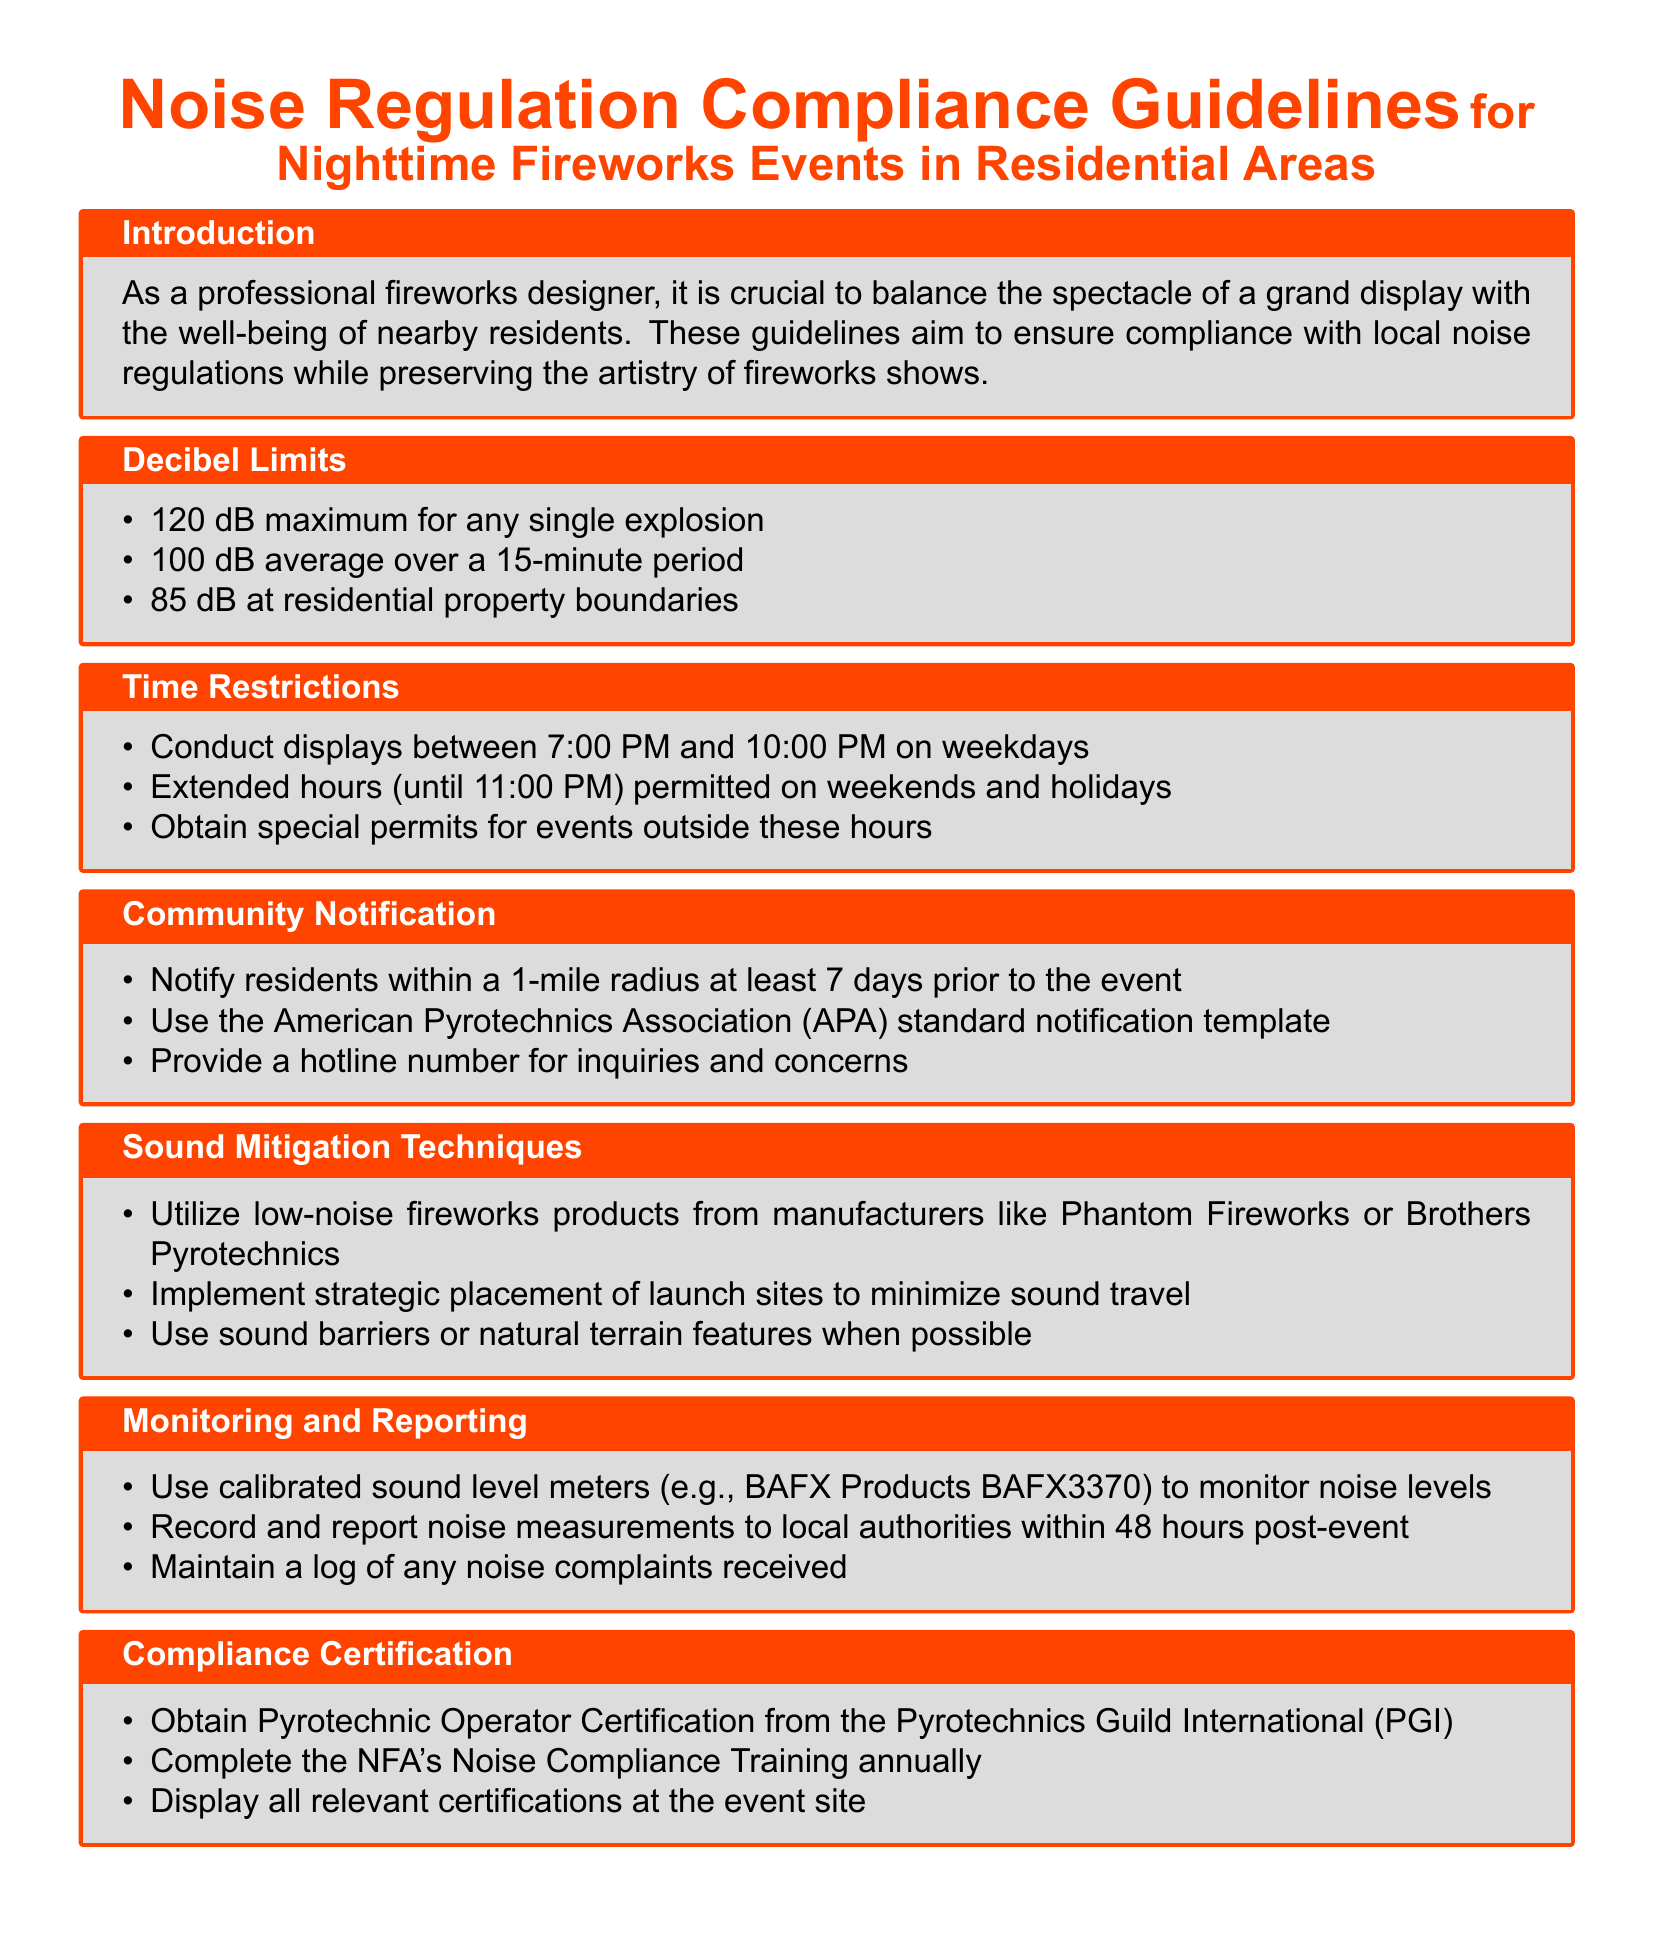What is the maximum decibel level for a single explosion? The document specifies that the maximum decibel level for a single explosion is 120 dB.
Answer: 120 dB What is the average decibel limit over a 15-minute period? The average decibel limit over a 15-minute period is stated as 100 dB in the guidelines.
Answer: 100 dB What hours are allowed for displays on weekdays? The guidelines specify that displays should be conducted between 7:00 PM and 10:00 PM on weekdays.
Answer: 7:00 PM to 10:00 PM How far in advance must residents be notified? Residents within a 1-mile radius must be notified at least 7 days prior to the event.
Answer: 7 days What type of fireworks products should be utilized for sound mitigation? The guidelines recommend utilizing low-noise fireworks products from specific manufacturers for sound mitigation.
Answer: Low-noise fireworks What is required to monitor noise levels? The document advises using calibrated sound level meters to monitor noise levels.
Answer: Calibrated sound level meters What certification is needed from the Pyrotechnics Guild International? The guidelines mention the necessity of obtaining Pyrotechnic Operator Certification from the Pyrotechnics Guild International.
Answer: Pyrotechnic Operator Certification Which training must be completed annually? The guidelines state that the NFA's Noise Compliance Training must be completed annually.
Answer: NFA's Noise Compliance Training 